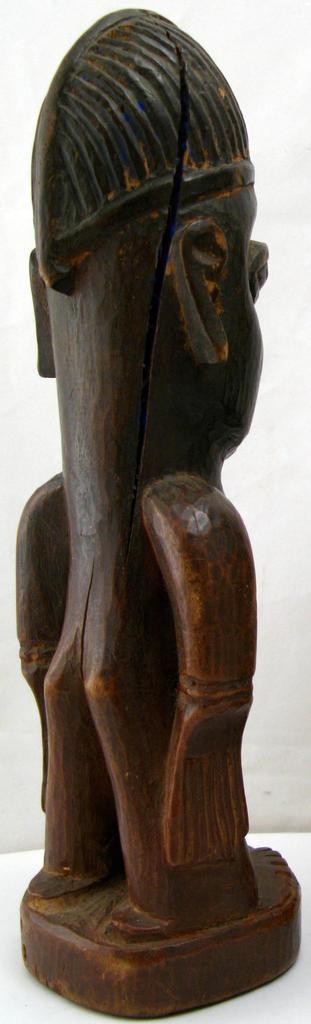Can you describe this image briefly? As we can see in the image, there is a sculpture with brown color. 